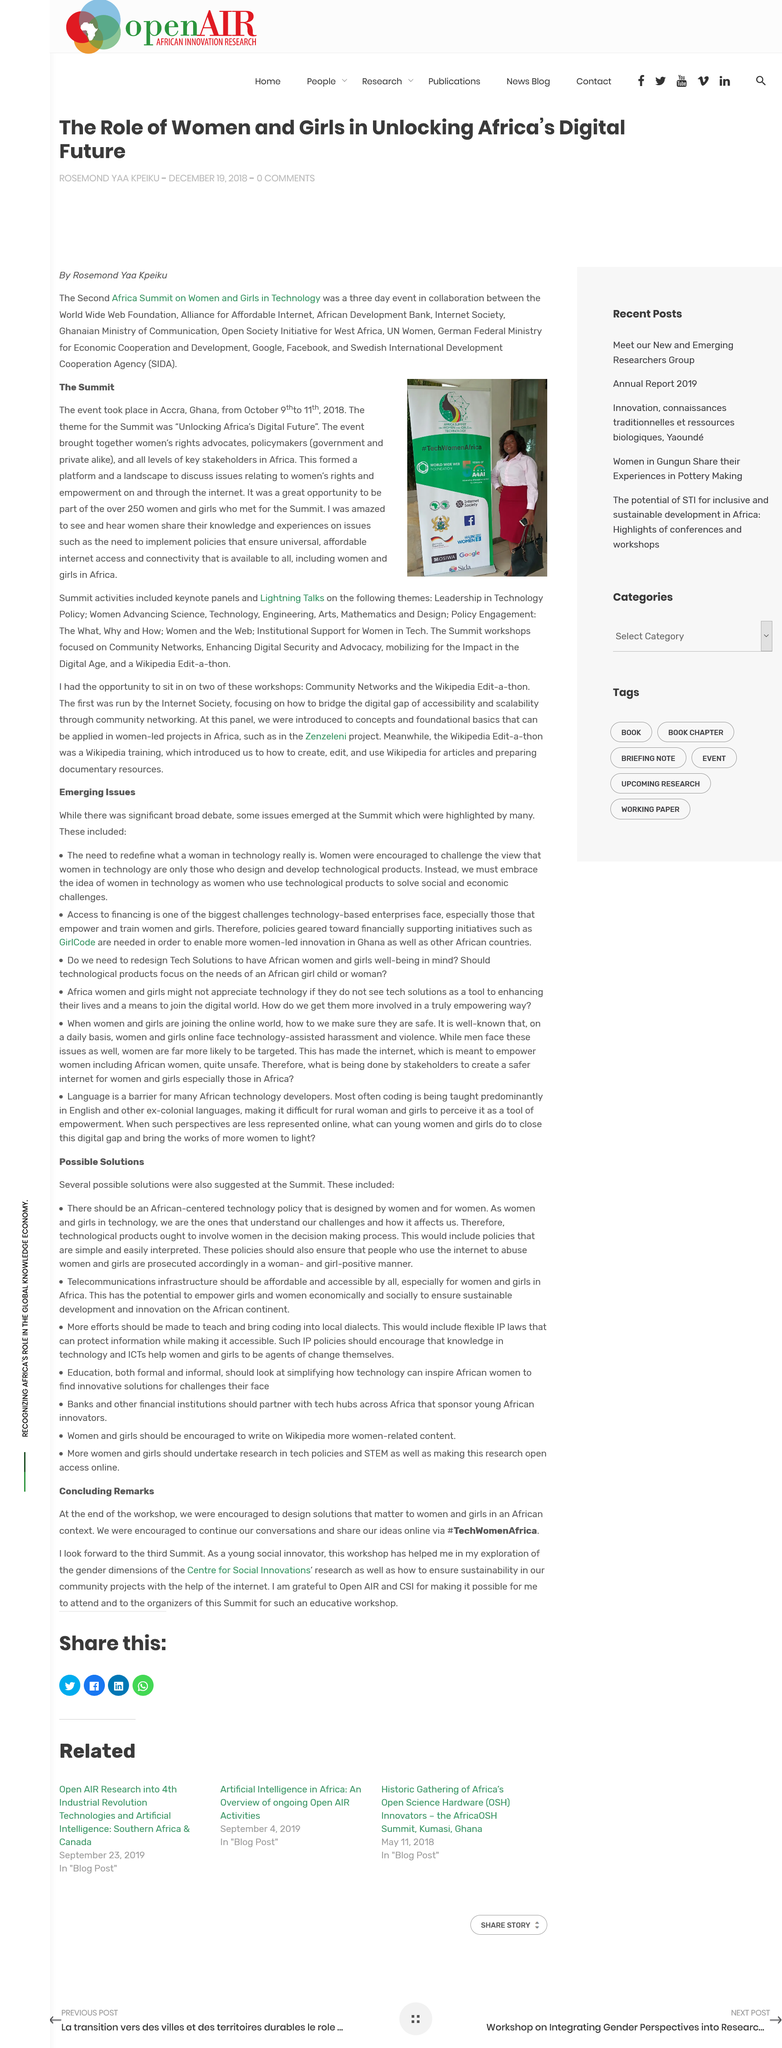Draw attention to some important aspects in this diagram. The solutions for women and girls that were encouraged were different depending on the context in which they were implemented. Solutions for women and girls in an African context were specifically encouraged. The article mentioned the tag #TechWomenAfrica. The author refers to the "workshop" as being "educative" in the "Concluding Remarks. 